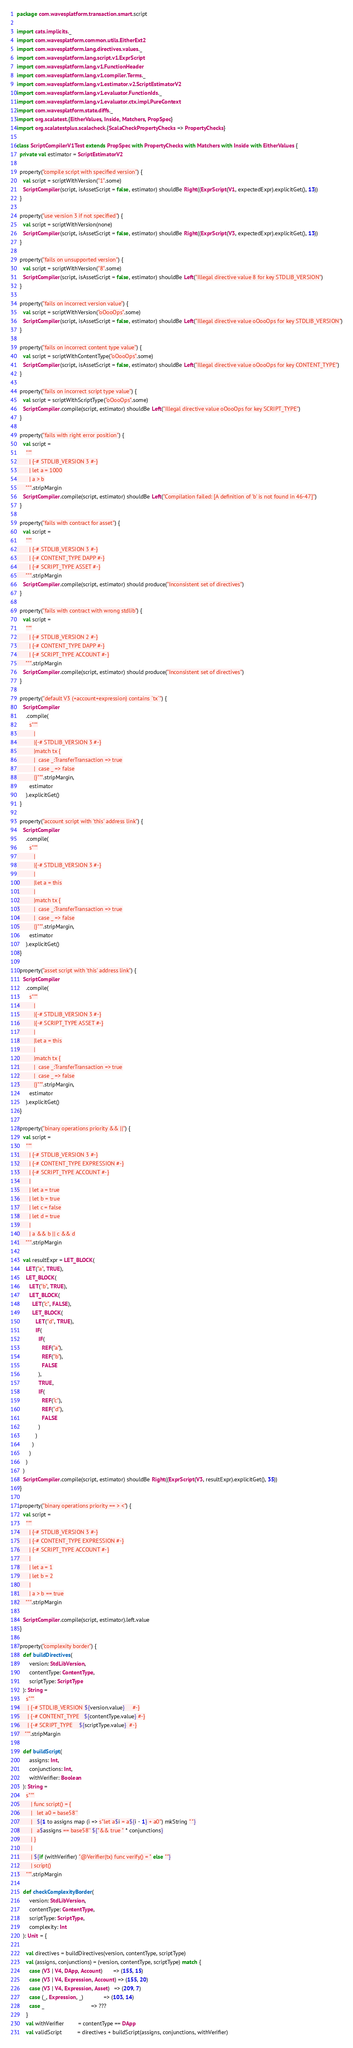Convert code to text. <code><loc_0><loc_0><loc_500><loc_500><_Scala_>package com.wavesplatform.transaction.smart.script

import cats.implicits._
import com.wavesplatform.common.utils.EitherExt2
import com.wavesplatform.lang.directives.values._
import com.wavesplatform.lang.script.v1.ExprScript
import com.wavesplatform.lang.v1.FunctionHeader
import com.wavesplatform.lang.v1.compiler.Terms._
import com.wavesplatform.lang.v1.estimator.v2.ScriptEstimatorV2
import com.wavesplatform.lang.v1.evaluator.FunctionIds._
import com.wavesplatform.lang.v1.evaluator.ctx.impl.PureContext
import com.wavesplatform.state.diffs._
import org.scalatest.{EitherValues, Inside, Matchers, PropSpec}
import org.scalatestplus.scalacheck.{ScalaCheckPropertyChecks => PropertyChecks}

class ScriptCompilerV1Test extends PropSpec with PropertyChecks with Matchers with Inside with EitherValues {
  private val estimator = ScriptEstimatorV2

  property("compile script with specified version") {
    val script = scriptWithVersion("1".some)
    ScriptCompiler(script, isAssetScript = false, estimator) shouldBe Right((ExprScript(V1, expectedExpr).explicitGet(), 13))
  }

  property("use version 3 if not specified") {
    val script = scriptWithVersion(none)
    ScriptCompiler(script, isAssetScript = false, estimator) shouldBe Right((ExprScript(V3, expectedExpr).explicitGet(), 13))
  }

  property("fails on unsupported version") {
    val script = scriptWithVersion("8".some)
    ScriptCompiler(script, isAssetScript = false, estimator) shouldBe Left("Illegal directive value 8 for key STDLIB_VERSION")
  }

  property("fails on incorrect version value") {
    val script = scriptWithVersion("oOooOps".some)
    ScriptCompiler(script, isAssetScript = false, estimator) shouldBe Left("Illegal directive value oOooOps for key STDLIB_VERSION")
  }

  property("fails on incorrect content type value") {
    val script = scriptWithContentType("oOooOps".some)
    ScriptCompiler(script, isAssetScript = false, estimator) shouldBe Left("Illegal directive value oOooOps for key CONTENT_TYPE")
  }

  property("fails on incorrect script type value") {
    val script = scriptWithScriptType("oOooOps".some)
    ScriptCompiler.compile(script, estimator) shouldBe Left("Illegal directive value oOooOps for key SCRIPT_TYPE")
  }

  property("fails with right error position") {
    val script =
      """
        | {-# STDLIB_VERSION 3 #-}
        | let a = 1000
        | a > b
      """.stripMargin
    ScriptCompiler.compile(script, estimator) shouldBe Left("Compilation failed: [A definition of 'b' is not found in 46-47]")
  }

  property("fails with contract for asset") {
    val script =
      """
        | {-# STDLIB_VERSION 3 #-}
        | {-# CONTENT_TYPE DAPP #-}
        | {-# SCRIPT_TYPE ASSET #-}
      """.stripMargin
    ScriptCompiler.compile(script, estimator) should produce("Inconsistent set of directives")
  }

  property("fails with contract with wrong stdlib") {
    val script =
      """
        | {-# STDLIB_VERSION 2 #-}
        | {-# CONTENT_TYPE DAPP #-}
        | {-# SCRIPT_TYPE ACCOUNT #-}
      """.stripMargin
    ScriptCompiler.compile(script, estimator) should produce("Inconsistent set of directives")
  }

  property("default V3 (+account+expression) contains `tx`") {
    ScriptCompiler
      .compile(
        s"""
           |
           |{-# STDLIB_VERSION 3 #-}
           |match tx {
           |  case _:TransferTransaction => true
           |  case _ => false
           |}""".stripMargin,
        estimator
      ).explicitGet()
  }

  property("account script with 'this' address link") {
    ScriptCompiler
      .compile(
        s"""
           |
           |{-# STDLIB_VERSION 3 #-}
           |
           |let a = this
           |
           |match tx {
           |  case _:TransferTransaction => true
           |  case _ => false
           |}""".stripMargin,
        estimator
      ).explicitGet()
  }

  property("asset script with 'this' address link") {
    ScriptCompiler
      .compile(
        s"""
           |
           |{-# STDLIB_VERSION 3 #-}
           |{-# SCRIPT_TYPE ASSET #-}
           |
           |let a = this
           |
           |match tx {
           |  case _:TransferTransaction => true
           |  case _ => false
           |}""".stripMargin,
        estimator
      ).explicitGet()
  }

  property("binary operations priority && ||") {
    val script =
      """
        | {-# STDLIB_VERSION 3 #-}
        | {-# CONTENT_TYPE EXPRESSION #-}
        | {-# SCRIPT_TYPE ACCOUNT #-}
        |
        | let a = true
        | let b = true
        | let c = false
        | let d = true
        |
        | a && b || c && d
      """.stripMargin

    val resultExpr = LET_BLOCK(
      LET("a", TRUE),
      LET_BLOCK(
        LET("b", TRUE),
        LET_BLOCK(
          LET("c", FALSE),
          LET_BLOCK(
            LET("d", TRUE),
            IF(
              IF(
                REF("a"),
                REF("b"),
                FALSE
              ),
              TRUE,
              IF(
                REF("c"),
                REF("d"),
                FALSE
              )
            )
          )
        )
      )
    )
    ScriptCompiler.compile(script, estimator) shouldBe Right((ExprScript(V3, resultExpr).explicitGet(), 35))
  }

  property("binary operations priority == > <") {
    val script =
      """
        | {-# STDLIB_VERSION 3 #-}
        | {-# CONTENT_TYPE EXPRESSION #-}
        | {-# SCRIPT_TYPE ACCOUNT #-}
        |
        | let a = 1
        | let b = 2
        |
        | a > b == true
      """.stripMargin

    ScriptCompiler.compile(script, estimator).left.value
  }

  property("complexity border") {
    def buildDirectives(
        version: StdLibVersion,
        contentType: ContentType,
        scriptType: ScriptType
    ): String =
      s"""
       | {-# STDLIB_VERSION ${version.value}     #-}
       | {-# CONTENT_TYPE   ${contentType.value} #-}
       | {-# SCRIPT_TYPE    ${scriptType.value}  #-}
     """.stripMargin

    def buildScript(
        assigns: Int,
        conjunctions: Int,
        withVerifier: Boolean
    ): String =
      s"""
         | func script() = {
         |   let a0 = base58''
         |   ${1 to assigns map (i => s"let a$i = a${i - 1} + a0") mkString " "}
         |   a$assigns == base58'' ${"&& true " * conjunctions}
         | }
         |
         | ${if (withVerifier) "@Verifier(tx) func verify() = " else ""}
         | script()
      """.stripMargin

    def checkComplexityBorder(
        version: StdLibVersion,
        contentType: ContentType,
        scriptType: ScriptType,
        complexity: Int
    ): Unit = {

      val directives = buildDirectives(version, contentType, scriptType)
      val (assigns, conjunctions) = (version, contentType, scriptType) match {
        case (V3 | V4, DApp, Account)       => (155, 15)
        case (V3 | V4, Expression, Account) => (155, 20)
        case (V3 | V4, Expression, Asset)   => (209, 7)
        case (_, Expression, _)             => (103, 14)
        case _                              => ???
      }
      val withVerifier         = contentType == DApp
      val validScript          = directives + buildScript(assigns, conjunctions, withVerifier)</code> 